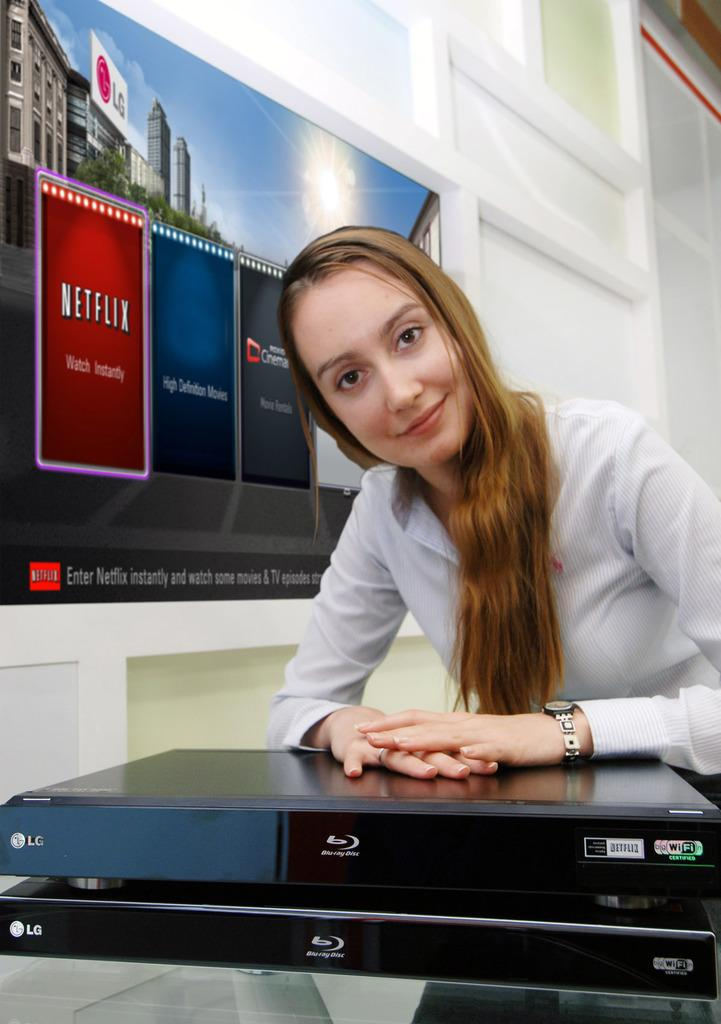Provide a one-sentence caption for the provided image. A smiling woman rests her hands on top of an LG Blue Ray player. 